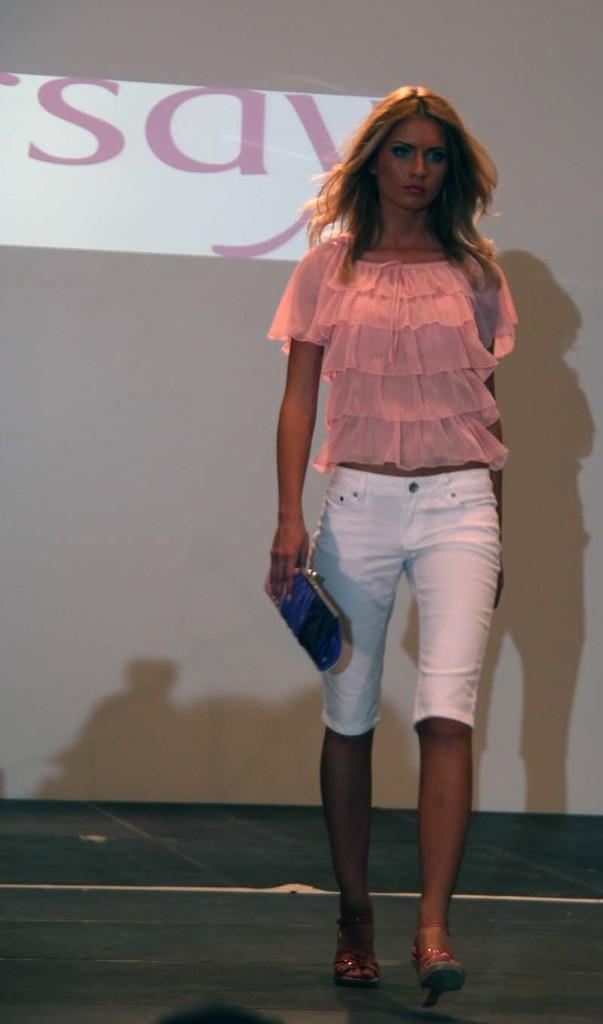How would you summarize this image in a sentence or two? In this image we can see a lady holding a wallet and walking. In the background there is a board. 